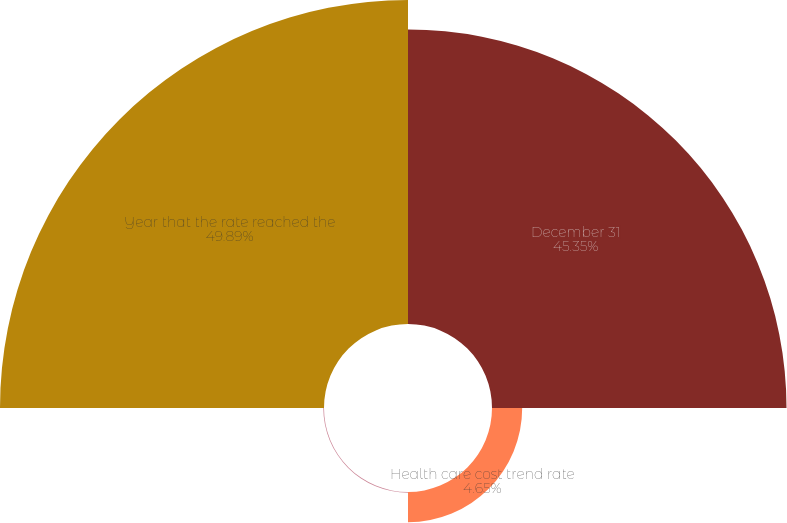<chart> <loc_0><loc_0><loc_500><loc_500><pie_chart><fcel>December 31<fcel>Health care cost trend rate<fcel>Rate to which the cost trend<fcel>Year that the rate reached the<nl><fcel>45.35%<fcel>4.65%<fcel>0.11%<fcel>49.89%<nl></chart> 